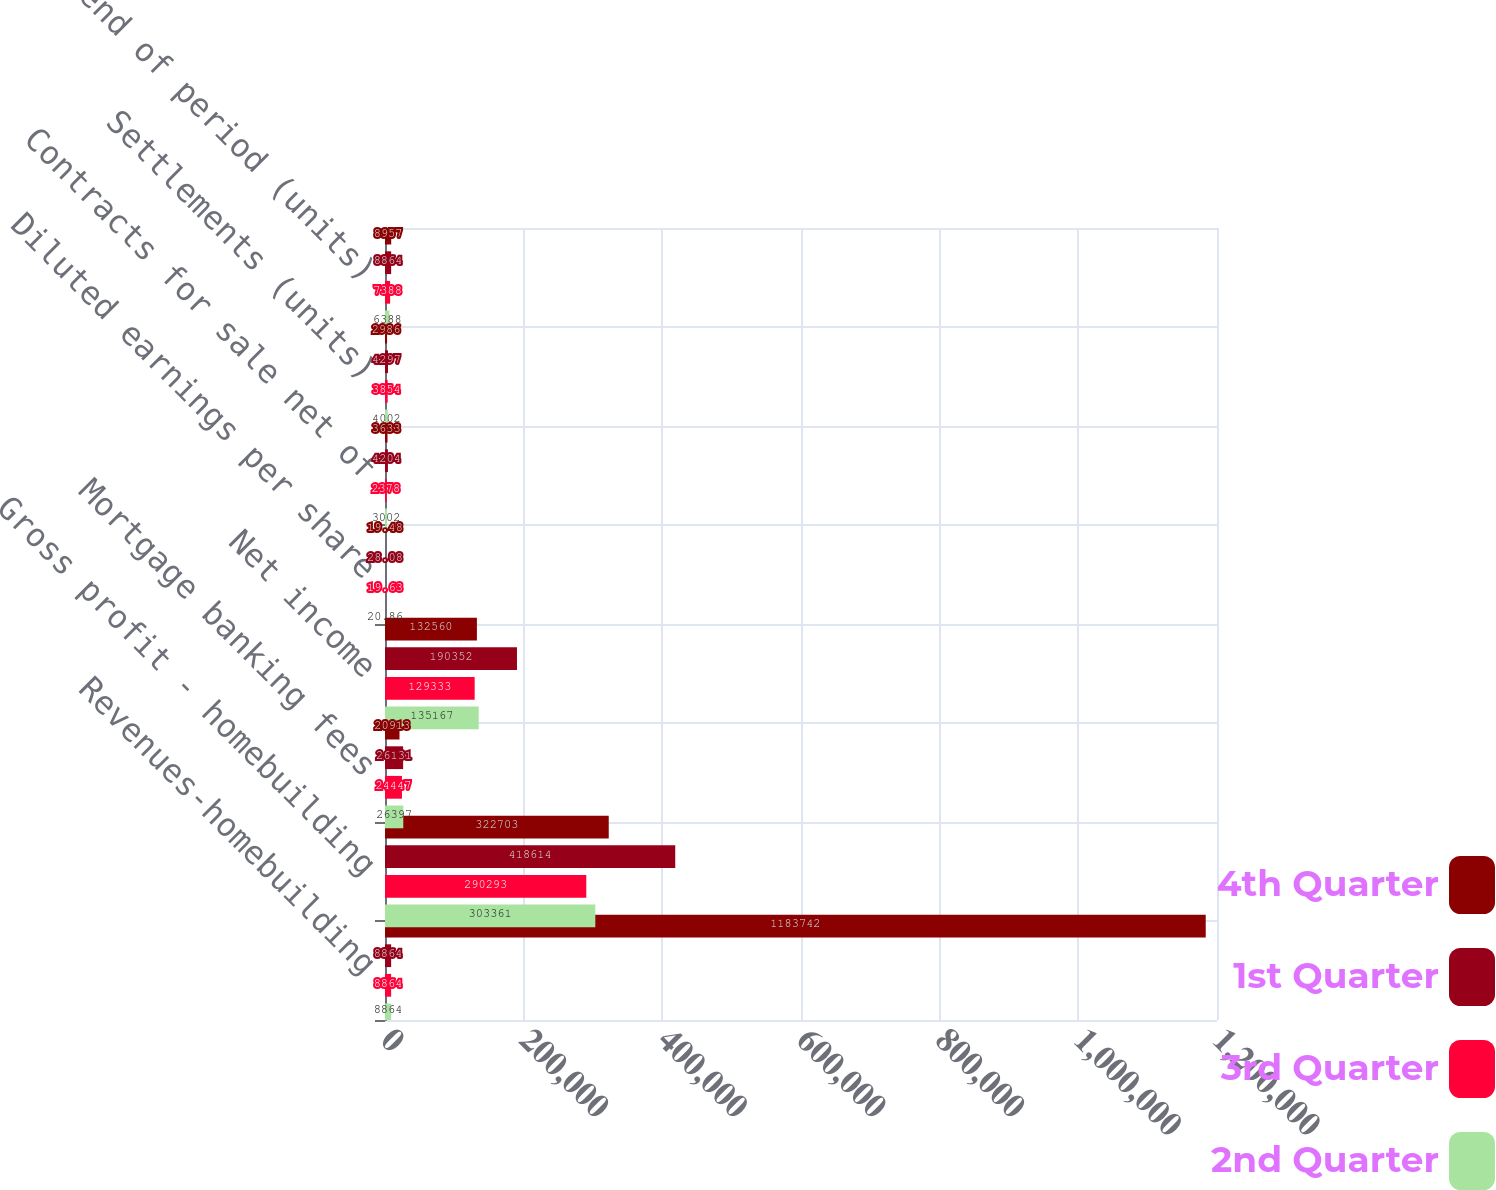Convert chart to OTSL. <chart><loc_0><loc_0><loc_500><loc_500><stacked_bar_chart><ecel><fcel>Revenues-homebuilding<fcel>Gross profit - homebuilding<fcel>Mortgage banking fees<fcel>Net income<fcel>Diluted earnings per share<fcel>Contracts for sale net of<fcel>Settlements (units)<fcel>Backlog end of period (units)<nl><fcel>4th Quarter<fcel>1.18374e+06<fcel>322703<fcel>20913<fcel>132560<fcel>19.48<fcel>3633<fcel>2986<fcel>8957<nl><fcel>1st Quarter<fcel>8864<fcel>418614<fcel>26131<fcel>190352<fcel>28.08<fcel>4204<fcel>4297<fcel>8864<nl><fcel>3rd Quarter<fcel>8864<fcel>290293<fcel>24447<fcel>129333<fcel>19.63<fcel>2378<fcel>3854<fcel>7388<nl><fcel>2nd Quarter<fcel>8864<fcel>303361<fcel>26397<fcel>135167<fcel>20.86<fcel>3002<fcel>4002<fcel>6388<nl></chart> 